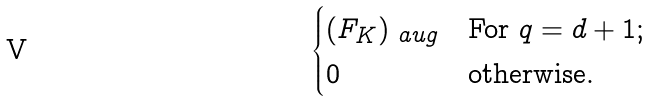Convert formula to latex. <formula><loc_0><loc_0><loc_500><loc_500>\begin{cases} ( F _ { K } ) _ { \ a u g } & \text {For $q=d+1$;} \\ 0 & \text {otherwise.} \end{cases}</formula> 